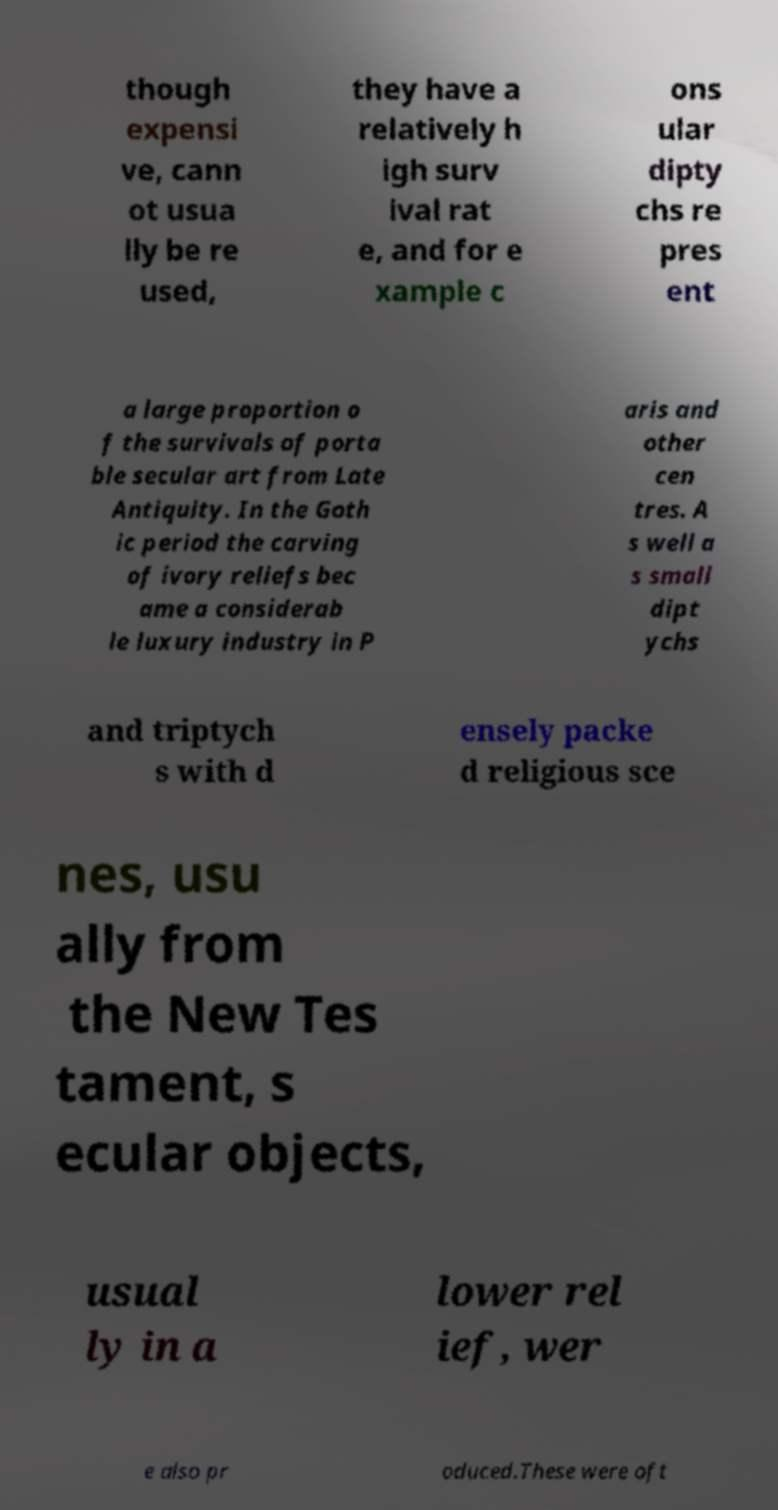I need the written content from this picture converted into text. Can you do that? though expensi ve, cann ot usua lly be re used, they have a relatively h igh surv ival rat e, and for e xample c ons ular dipty chs re pres ent a large proportion o f the survivals of porta ble secular art from Late Antiquity. In the Goth ic period the carving of ivory reliefs bec ame a considerab le luxury industry in P aris and other cen tres. A s well a s small dipt ychs and triptych s with d ensely packe d religious sce nes, usu ally from the New Tes tament, s ecular objects, usual ly in a lower rel ief, wer e also pr oduced.These were oft 